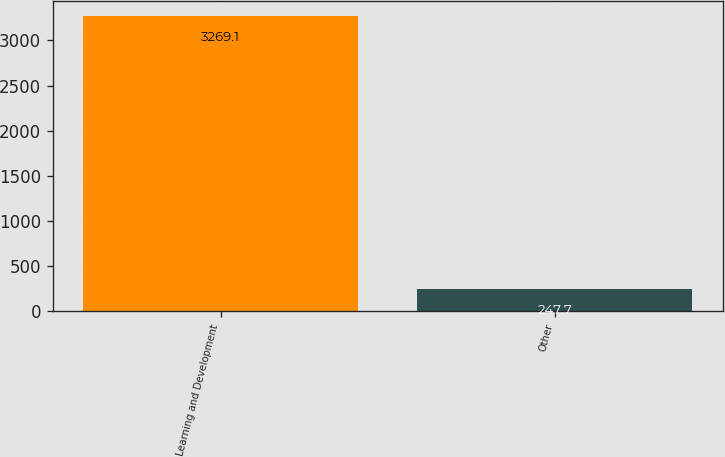Convert chart. <chart><loc_0><loc_0><loc_500><loc_500><bar_chart><fcel>Learning and Development<fcel>Other<nl><fcel>3269.1<fcel>247.7<nl></chart> 